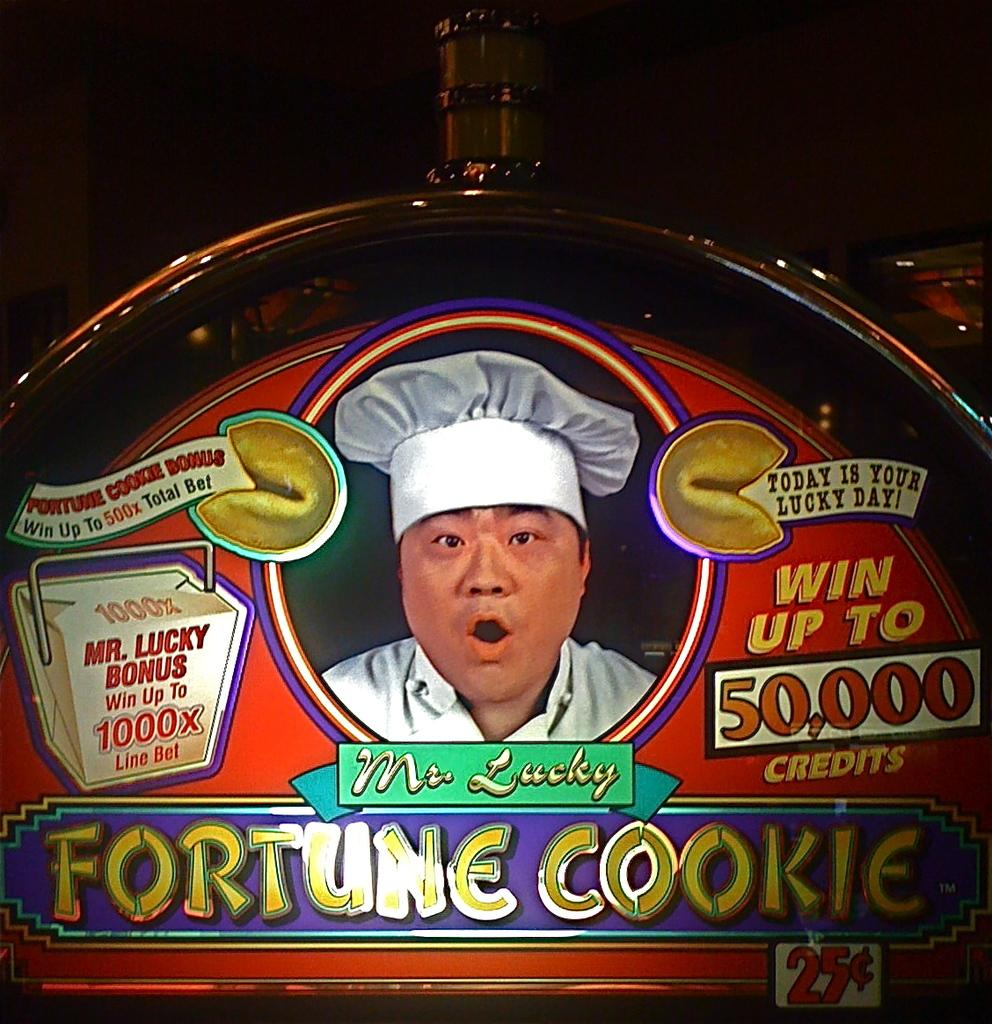What type of image is being described? The image is a poster. Who or what is shown on the poster? There is a person depicted on the poster. Are there any words or phrases on the poster? Yes, there is text on the poster. How would you describe the overall appearance of the poster? The background of the poster is dark. What shape is the observation window on the poster? There is no observation window present on the poster, as it is a poster featuring a person and text. Can you see any cracks in the person's face on the poster? There are no cracks visible on the person's face in the poster, as it is a flat, two-dimensional image. 